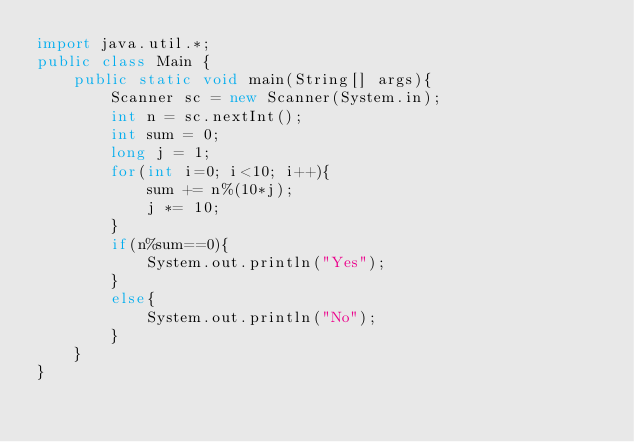Convert code to text. <code><loc_0><loc_0><loc_500><loc_500><_Java_>import java.util.*;
public class Main {
    public static void main(String[] args){
        Scanner sc = new Scanner(System.in);
        int n = sc.nextInt();
        int sum = 0;
        long j = 1;
        for(int i=0; i<10; i++){
            sum += n%(10*j);
            j *= 10;
        }
        if(n%sum==0){
            System.out.println("Yes");
        }
        else{
            System.out.println("No");
        }
    }
}
</code> 